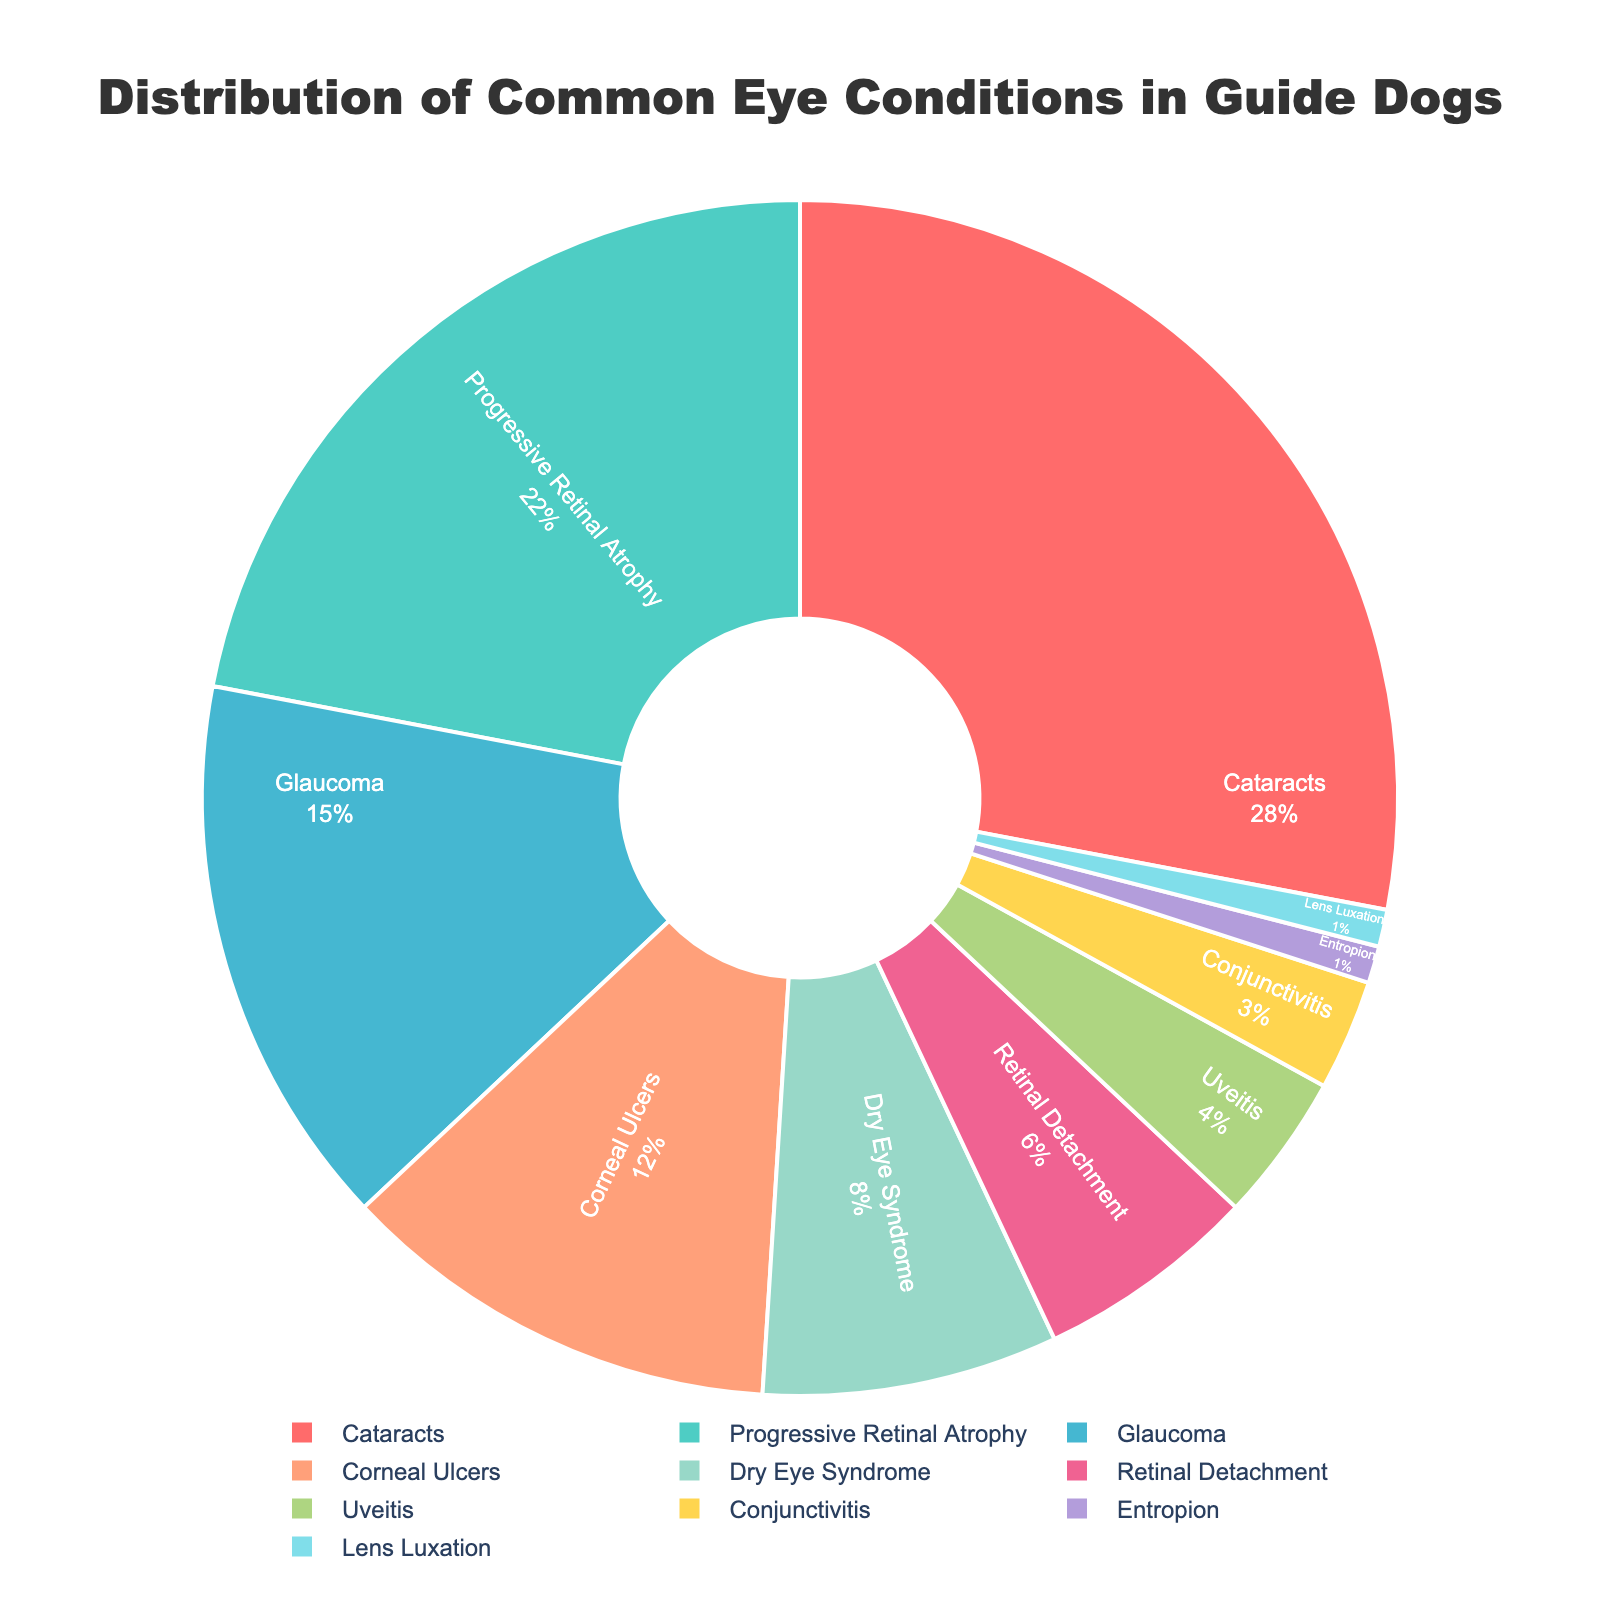Which eye condition is the most common in guide dogs? The pie chart shows that Cataracts has the largest segment. Hence, Cataracts is the most common eye condition.
Answer: Cataracts Which eye condition is the least common in guide dogs? The pie chart shows very small segments for Entropion and Lens Luxation, both at 1%. Therefore, these two conditions are the least common.
Answer: Entropion and Lens Luxation What is the combined percentage of dogs with Cataracts and Progressive Retinal Atrophy? According to the chart, Cataracts is 28% and Progressive Retinal Atrophy is 22%. So, the combined percentage is 28% + 22% = 50%.
Answer: 50% How does the percentage of guide dogs with Glaucoma compare to those with Dry Eye Syndrome? Glaucoma has a percentage of 15%, while Dry Eye Syndrome is at 8%. Hence, Glaucoma is more common than Dry Eye Syndrome.
Answer: Glaucoma is more common than Dry Eye Syndrome What percentage of guide dogs have Corneal Ulcers or Conjunctivitis? Corneal Ulcers account for 12% and Conjunctivitis is 3%. Therefore, their combined percentage is 12% + 3% = 15%.
Answer: 15% Which condition has a larger representation: Uveitis or Retinal Detachment? The pie chart shows Uveitis at 4% and Retinal Detachment at 6%. Therefore, Retinal Detachment has a larger representation.
Answer: Retinal Detachment What is the combined percentage of all conditions that account for less than 5% of cases each? Conditions with less than 5% are Uveitis (4%), Conjunctivitis (3%), Entropion (1%), and Lens Luxation (1%). Adding these together gives 4% + 3% + 1% + 1% = 9%.
Answer: 9% Are there more guide dogs affected by Cataracts or by Glaucoma and Corneal Ulcers combined? Cataracts affect 28%. Glaucoma affects 15% and Corneal Ulcers affect 12%, so combined they affect 15% + 12% = 27%. Therefore, more guide dogs are affected by Cataracts.
Answer: Cataracts How many eye conditions collectively account for more than 20% each? The conditions that account for more than 20% each are Cataracts (28%) and Progressive Retinal Atrophy (22%).
Answer: 2 Which segment is represented by the light blue color? By visual inspection, the light blue segment corresponds to Glaucoma.
Answer: Glaucoma 